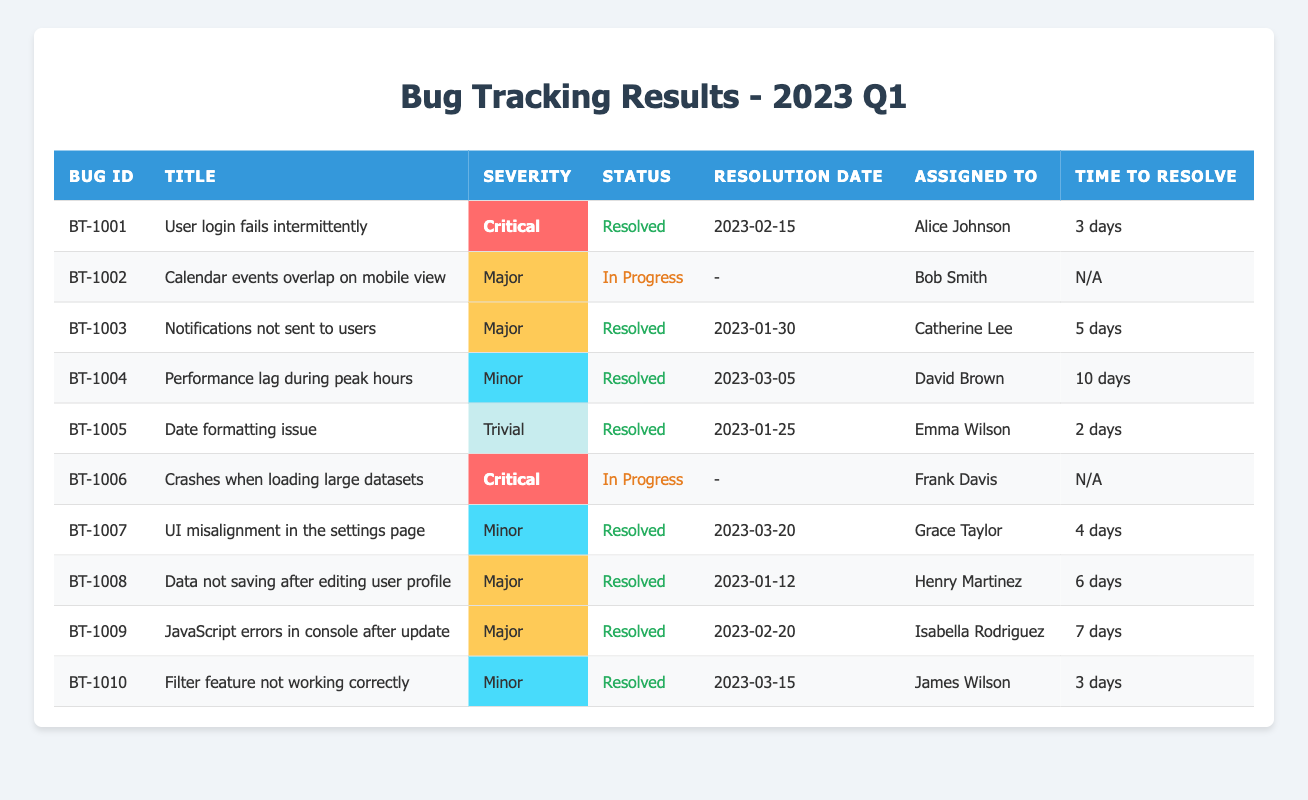What is the Bug ID for the issue related to user login? The table lists the issue "User login fails intermittently" with Bug ID "BT-1001" under the relevant column.
Answer: BT-1001 How many bugs have been resolved in total? By checking the status column and counting all entries marked as "Resolved," there are a total of 7 bugs that have been resolved.
Answer: 7 Who is assigned to the bug with the highest severity? The bug with the highest severity is "User login fails intermittently," assigned to Alice Johnson. This can be determined by looking at the severity column and finding the critical bug.
Answer: Alice Johnson What is the average time to resolve for all resolved bugs? Adding the time taken to resolve for each resolved bug: 3 + 5 + 10 + 2 + 6 + 7 + 3 = 36 days. Dividing this by the number of resolved bugs (7) gives an average of 36 / 7 = approximately 5.14 days.
Answer: Approximately 5.14 days Is there any bug with a "Critical" severity that is still "In Progress"? Yes, the bug "Crashes when loading large datasets" (BT-1006) has a severity of "Critical" and is marked as "In Progress," as observed in the severity and status columns.
Answer: Yes How many days did it take to resolve the bug related to "Performance lag during peak hours"? The time to resolve for "Performance lag during peak hours," assigned to David Brown, is listed as "10 days" in the table.
Answer: 10 days Which bugs were resolved on or after March 1, 2023? The resolved bugs after March 1, 2023, are "UI misalignment in the settings page" (March 20) and "Filter feature not working correctly" (March 15). Thus, counting these gives us 2 resolved bugs after that date.
Answer: 2 What is the status of the bug with title "Calendar events overlap on mobile view"? The status of the bug titled "Calendar events overlap on mobile view" (BT-1002) is "In Progress" as indicated in the status column.
Answer: In Progress Which assignee resolved the most bugs? By counting the resolved bugs assigned to each person, Alice Johnson, Catherine Lee, and Emma Wilson each resolved 1 bug, while David Brown has resolved 1 bug and Grace Taylor has resolved 1 bug as well. None have more than one resolved.
Answer: They are tied; all resolved 1 bug each What is the total count of bugs with "Major" severity that are still "In Progress"? Only one bug, "Crashes when loading large datasets," is of "Critical" severity and is "In Progress." Thus, the total count of Major severity that is still in progress is 1.
Answer: 1 